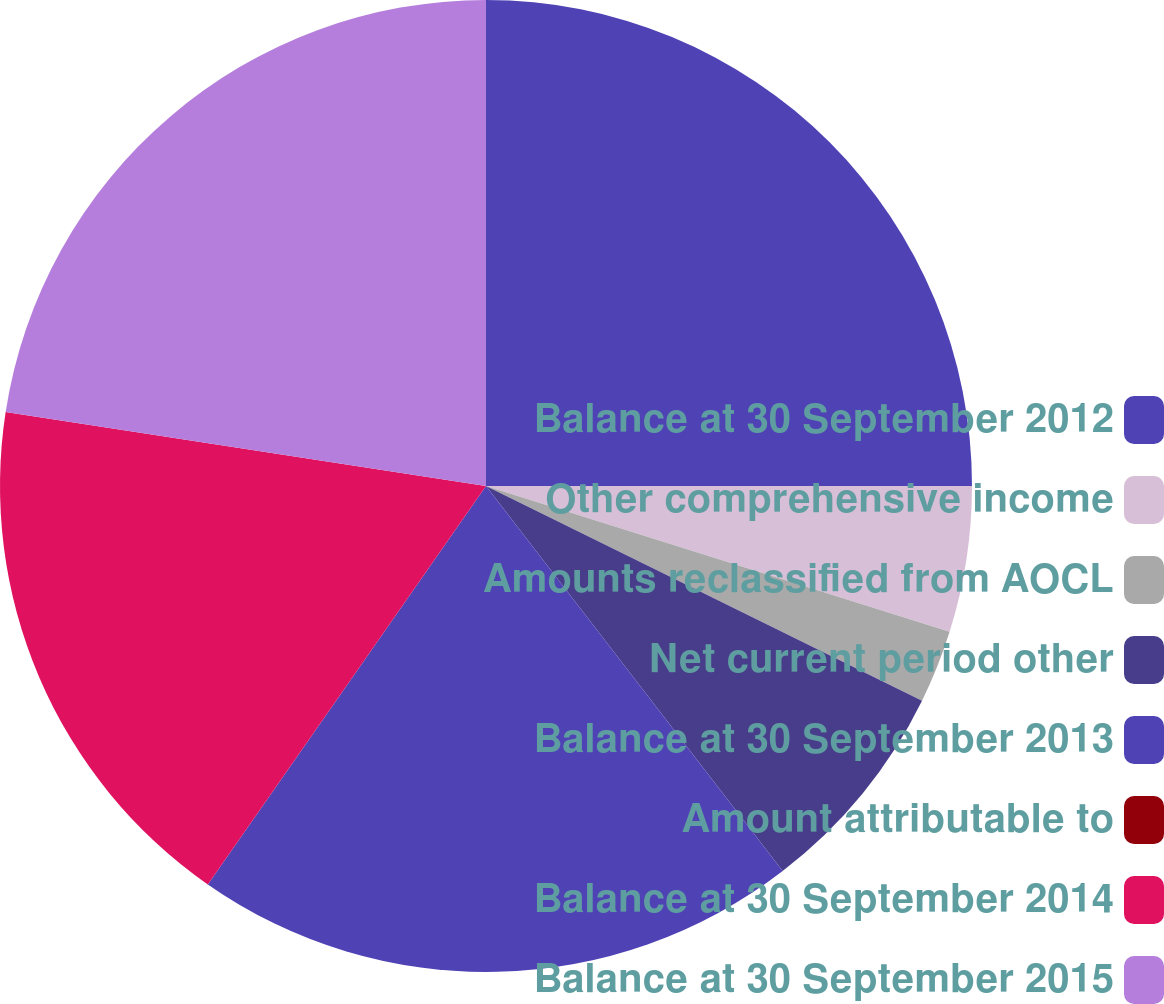Convert chart. <chart><loc_0><loc_0><loc_500><loc_500><pie_chart><fcel>Balance at 30 September 2012<fcel>Other comprehensive income<fcel>Amounts reclassified from AOCL<fcel>Net current period other<fcel>Balance at 30 September 2013<fcel>Amount attributable to<fcel>Balance at 30 September 2014<fcel>Balance at 30 September 2015<nl><fcel>25.0%<fcel>4.85%<fcel>2.43%<fcel>7.27%<fcel>20.15%<fcel>0.0%<fcel>17.73%<fcel>22.57%<nl></chart> 